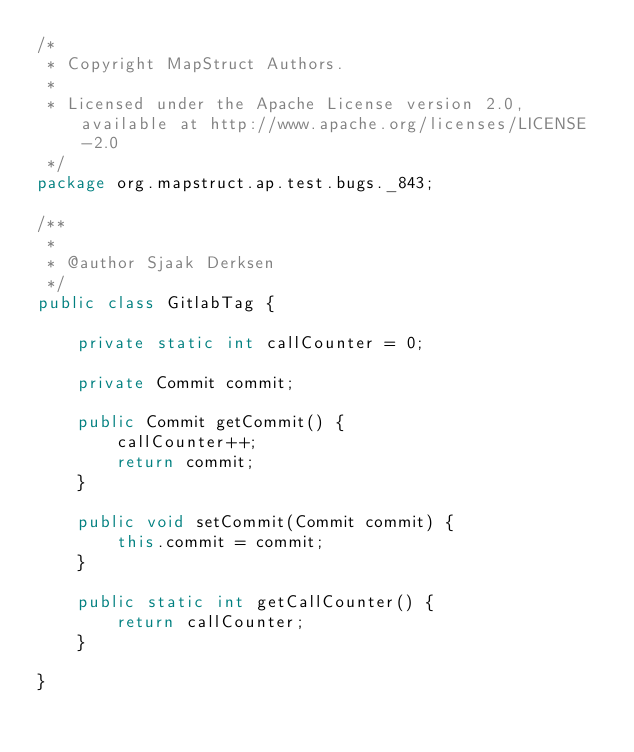<code> <loc_0><loc_0><loc_500><loc_500><_Java_>/*
 * Copyright MapStruct Authors.
 *
 * Licensed under the Apache License version 2.0, available at http://www.apache.org/licenses/LICENSE-2.0
 */
package org.mapstruct.ap.test.bugs._843;

/**
 *
 * @author Sjaak Derksen
 */
public class GitlabTag {

    private static int callCounter = 0;

    private Commit commit;

    public Commit getCommit() {
        callCounter++;
        return commit;
    }

    public void setCommit(Commit commit) {
        this.commit = commit;
    }

    public static int getCallCounter() {
        return callCounter;
    }

}
</code> 